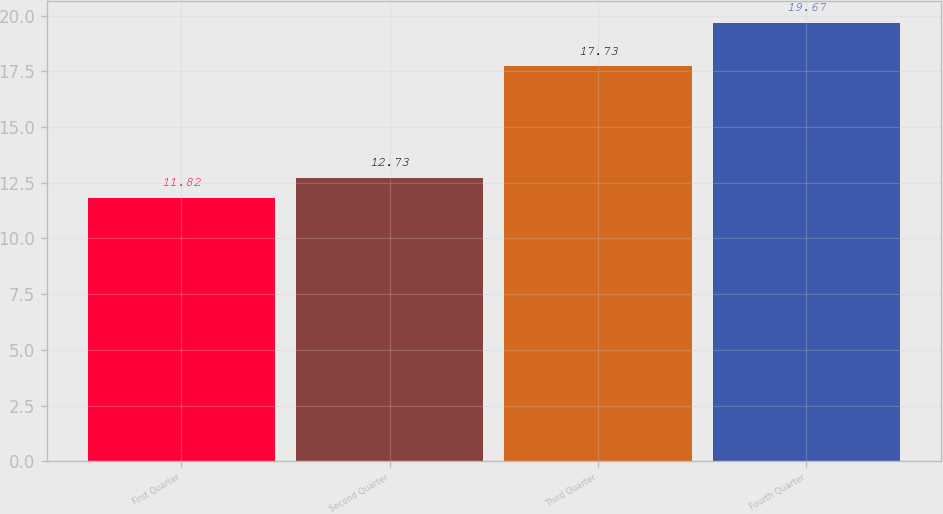Convert chart to OTSL. <chart><loc_0><loc_0><loc_500><loc_500><bar_chart><fcel>First Quarter<fcel>Second Quarter<fcel>Third Quarter<fcel>Fourth Quarter<nl><fcel>11.82<fcel>12.73<fcel>17.73<fcel>19.67<nl></chart> 